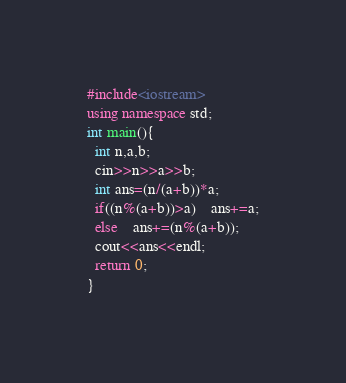Convert code to text. <code><loc_0><loc_0><loc_500><loc_500><_C++_>#include<iostream>
using namespace std;
int main(){
  int n,a,b;
  cin>>n>>a>>b;
  int ans=(n/(a+b))*a;
  if((n%(a+b))>a)	ans+=a;
  else	ans+=(n%(a+b));
  cout<<ans<<endl;
  return 0;
}</code> 